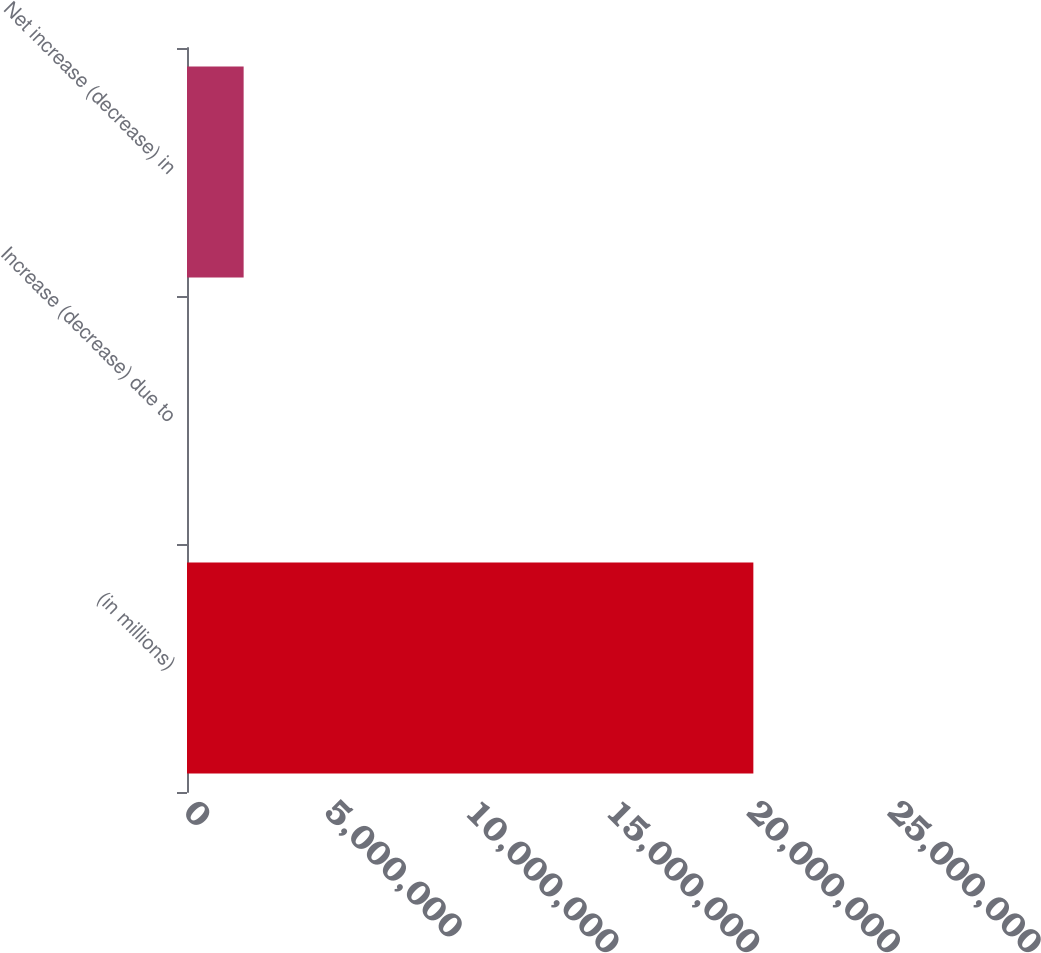Convert chart. <chart><loc_0><loc_0><loc_500><loc_500><bar_chart><fcel>(in millions)<fcel>Increase (decrease) due to<fcel>Net increase (decrease) in<nl><fcel>2.0112e+07<fcel>22.4<fcel>2.01122e+06<nl></chart> 